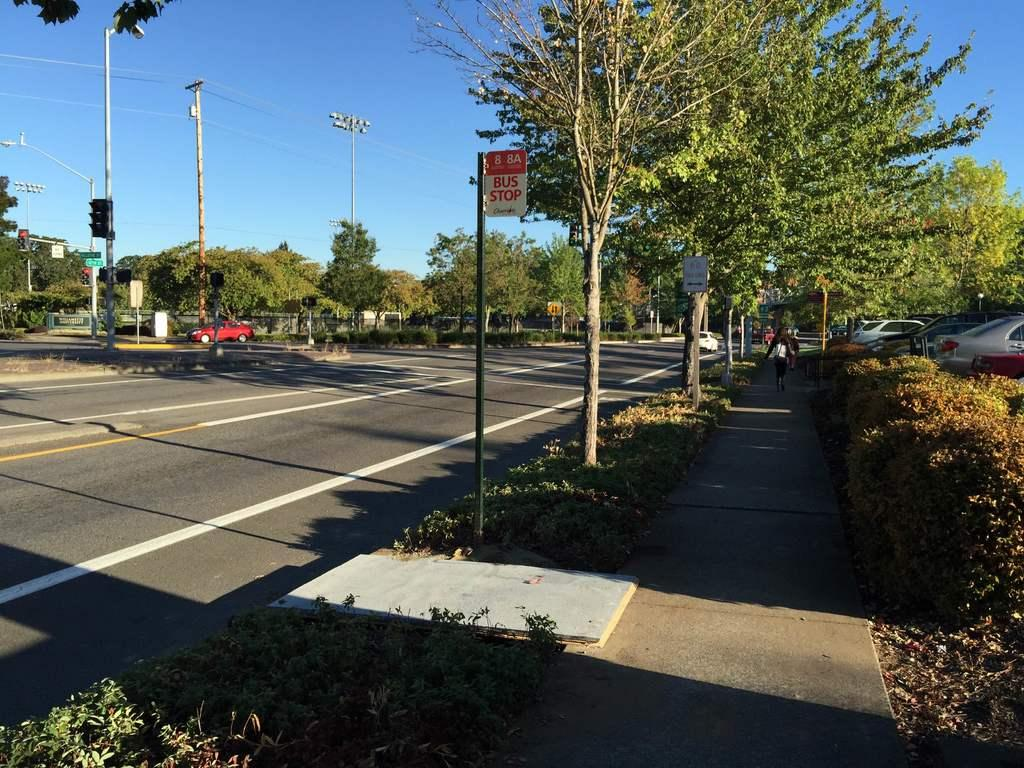What is the main feature of the image? There is a road in the image. What else can be seen on the road? There are vehicles in the image. What type of natural elements are present in the image? There are trees and plants in the image. What are the poles with wires used for? The poles with wires are likely used for electrical or communication purposes. What is visible in the background of the image? The sky is visible in the image. What brand of toothpaste is being advertised on the road in the image? There is no toothpaste or advertisement present in the image. 